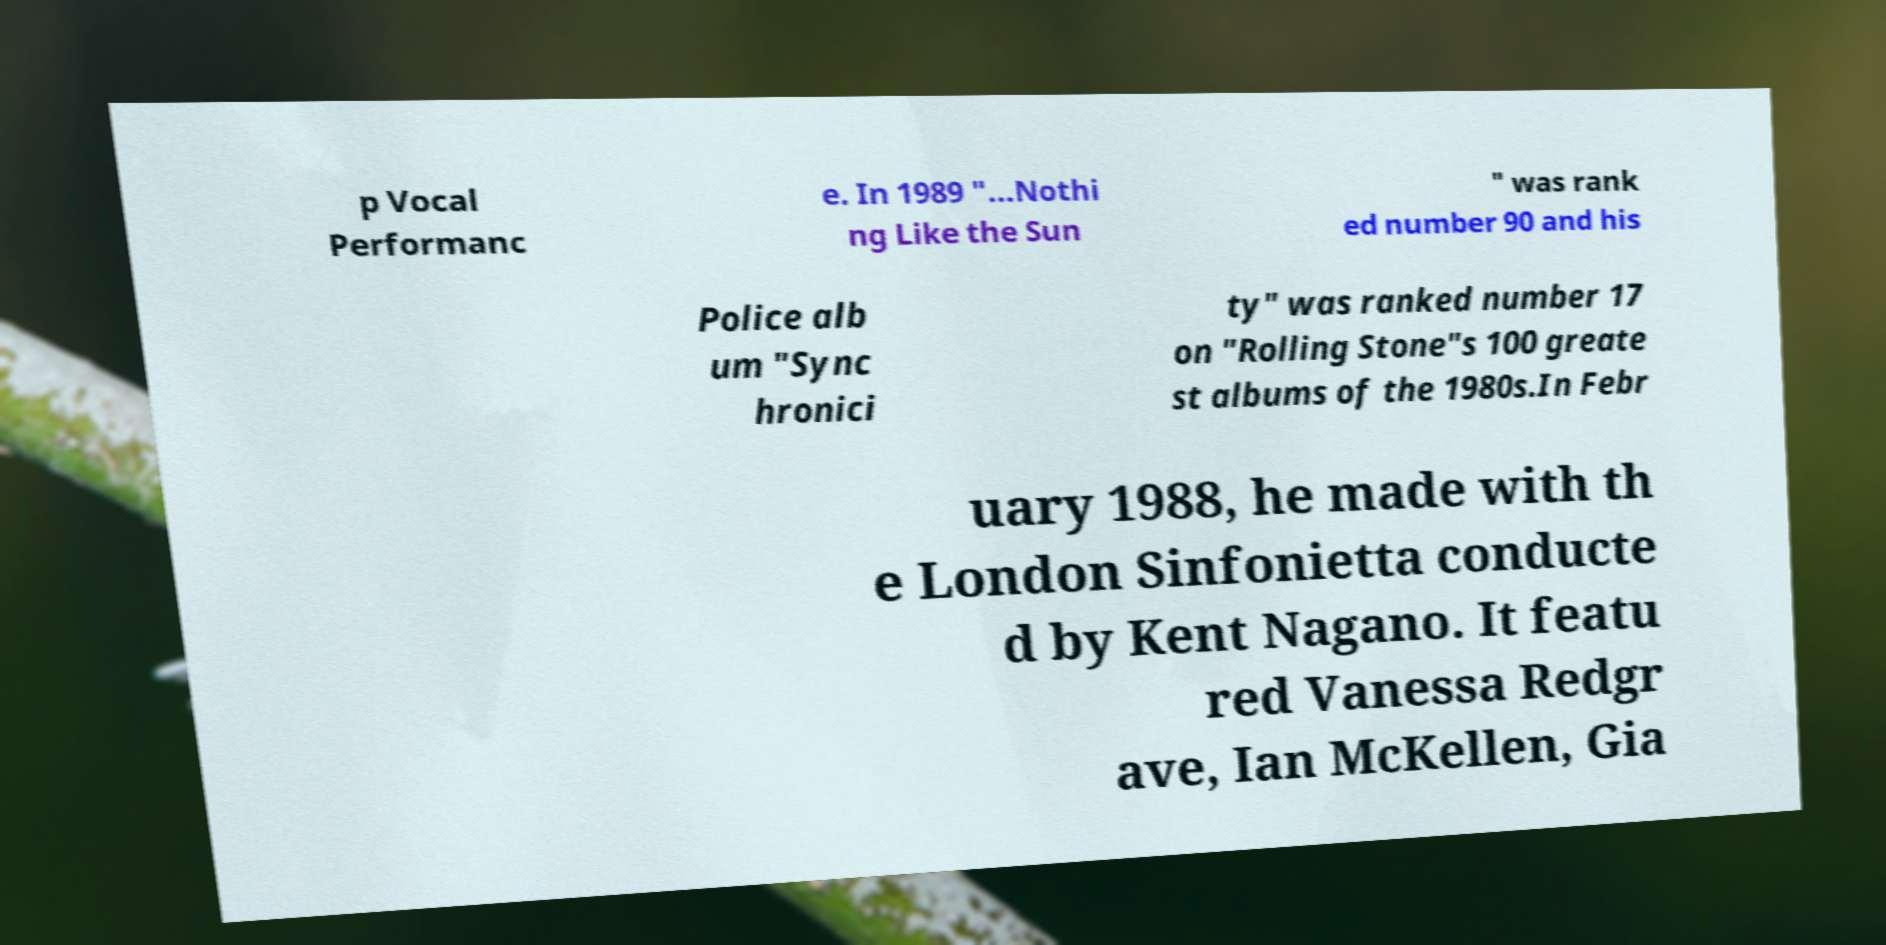I need the written content from this picture converted into text. Can you do that? p Vocal Performanc e. In 1989 "...Nothi ng Like the Sun " was rank ed number 90 and his Police alb um "Sync hronici ty" was ranked number 17 on "Rolling Stone"s 100 greate st albums of the 1980s.In Febr uary 1988, he made with th e London Sinfonietta conducte d by Kent Nagano. It featu red Vanessa Redgr ave, Ian McKellen, Gia 